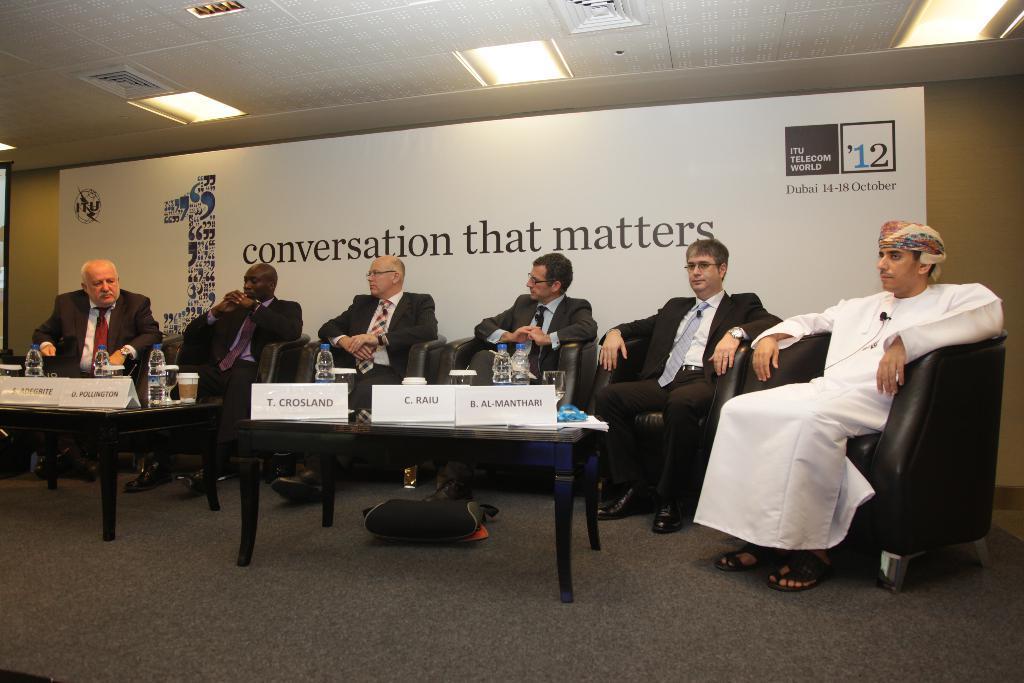Can you describe this image briefly? In this image in the center there are some people who are sitting on chairs, and there are two tables. On the tables there are some name plates, bottles and glasses. In the background there is a wall and boards, on the top there is ceiling and some lights. At the bottom there is a floor. 